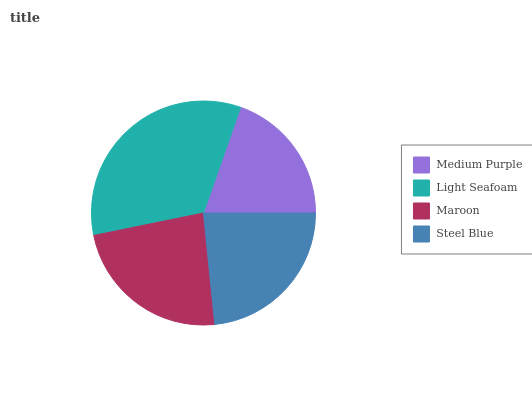Is Medium Purple the minimum?
Answer yes or no. Yes. Is Light Seafoam the maximum?
Answer yes or no. Yes. Is Maroon the minimum?
Answer yes or no. No. Is Maroon the maximum?
Answer yes or no. No. Is Light Seafoam greater than Maroon?
Answer yes or no. Yes. Is Maroon less than Light Seafoam?
Answer yes or no. Yes. Is Maroon greater than Light Seafoam?
Answer yes or no. No. Is Light Seafoam less than Maroon?
Answer yes or no. No. Is Maroon the high median?
Answer yes or no. Yes. Is Steel Blue the low median?
Answer yes or no. Yes. Is Steel Blue the high median?
Answer yes or no. No. Is Light Seafoam the low median?
Answer yes or no. No. 